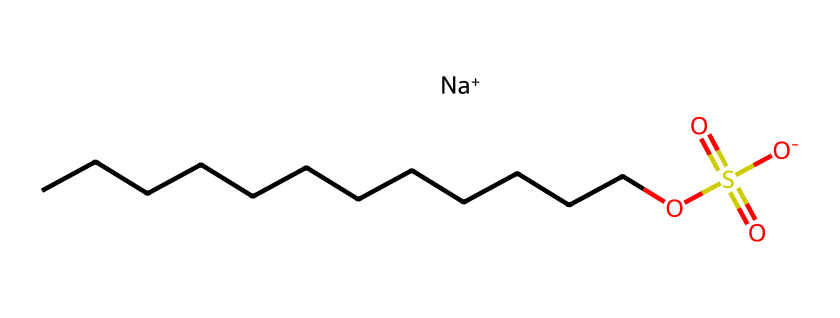what is the molecular formula of sodium lauryl sulfate? To derive the molecular formula from the SMILES representation, we count the elements: C (carbon), H (hydrogen), O (oxygen), S (sulfur), and Na (sodium). The structure shows 12 carbon atoms (C), 25 hydrogen atoms (H), 1 sulfur atom (S), 4 oxygen atoms (O), and 1 sodium atom (Na). Therefore, the molecular formula is C12H25NaO4S.
Answer: C12H25NaO4S how many carbon atoms are present in sodium lauryl sulfate? By analyzing the chemical structure through the SMILES, we note that there is a long hydrocarbon chain indicated by the 'CCCCCCCCCCCC' part, which clearly shows there are 12 carbon atoms.
Answer: 12 what functional groups are present in sodium lauryl sulfate? From the SMILES representation, we can identify key features: a long alkyl chain, a sulfate group (denoted by 'OS(=O)(=O)[O-]'), and a sodium ion. This indicates the presence of a sulfate functional group, which is characteristic of surfactants.
Answer: sulfate group is sodium lauryl sulfate an anionic surfactant? The presence of the negatively charged sulfate group ('[O-]') indicates that sodium lauryl sulfate carries a negative charge in solution, thus confirming it is classified as an anionic surfactant.
Answer: yes how does the hydrophilic part of sodium lauryl sulfate contribute to its surfactant properties? In the structure, the sulfate group at one end provides a polar, hydrophilic (water-attracting) region, while the long carbon chain is hydrophobic (water-repelling). This duality reduces surface tension between oil and water, allowing sodium lauryl sulfate to effectively cleanse and emulsify.
Answer: hydrophilic region what is the sodium ion's role in sodium lauryl sulfate? In the structure, the sodium ion ('[Na+]') acts as a counterion that balances the negative charge of the sulfate group, helping to solubilize the molecule in water and enhancing its surfactant properties.
Answer: counterion how many oxygen atoms are linked to sulfur in sodium lauryl sulfate? From the sulfate group in the SMILES representation ('OS(=O)(=O)[O-]'), we can see the sulfur atom is connected to four oxygen atoms total, with the two oxygen atoms bonded via double bonds and one oxygen with a negative charge, hence three linked directly to sulfur.
Answer: 4 